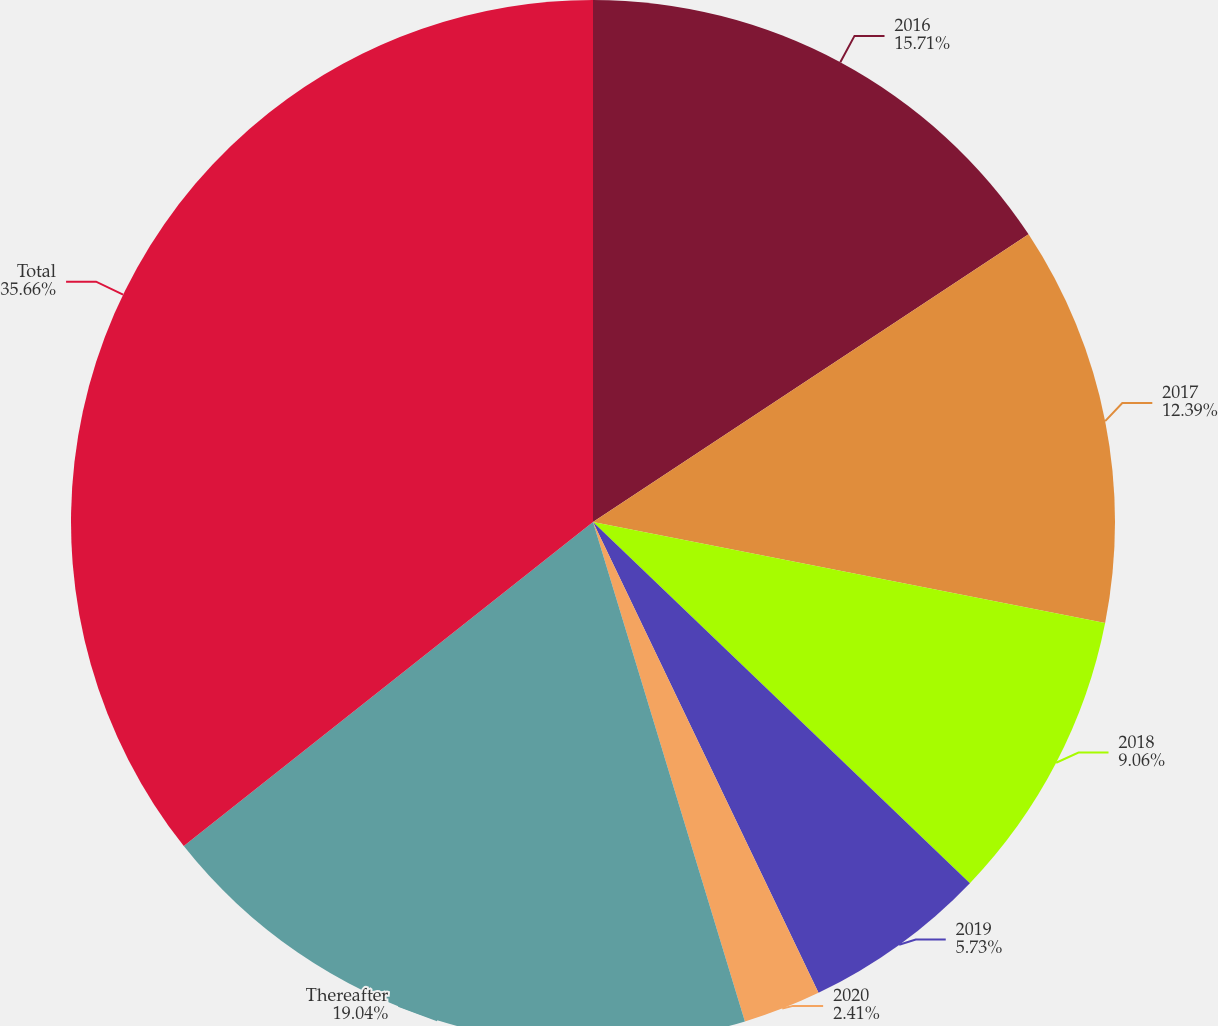Convert chart. <chart><loc_0><loc_0><loc_500><loc_500><pie_chart><fcel>2016<fcel>2017<fcel>2018<fcel>2019<fcel>2020<fcel>Thereafter<fcel>Total<nl><fcel>15.71%<fcel>12.39%<fcel>9.06%<fcel>5.73%<fcel>2.41%<fcel>19.04%<fcel>35.66%<nl></chart> 